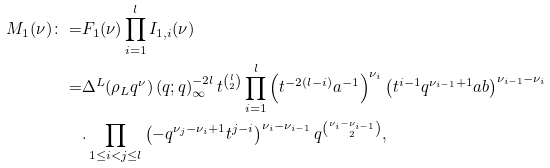<formula> <loc_0><loc_0><loc_500><loc_500>M _ { 1 } ( \nu ) \colon = & F _ { 1 } ( \nu ) \prod _ { i = 1 } ^ { l } I _ { 1 , i } ( \nu ) \\ = & \Delta ^ { L } ( \rho _ { L } q ^ { \nu } ) \left ( q ; q \right ) _ { \infty } ^ { - 2 l } t ^ { \binom { l } { 2 } } \prod _ { i = 1 } ^ { l } \left ( t ^ { - 2 ( l - i ) } a ^ { - 1 } \right ) ^ { \nu _ { i } } \left ( t ^ { i - 1 } q ^ { \nu _ { i - 1 } + 1 } a b \right ) ^ { \nu _ { i - 1 } - \nu _ { i } } \\ & . \prod _ { 1 \leq i < j \leq l } \left ( - q ^ { \nu _ { j } - \nu _ { i } + 1 } t ^ { j - i } \right ) ^ { \nu _ { i } - \nu _ { i - 1 } } q ^ { \binom { \nu _ { i } - \nu _ { i - 1 } } { 2 } } , \\</formula> 